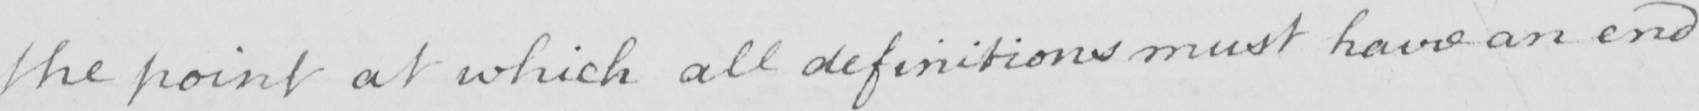Please provide the text content of this handwritten line. the point at which all definitions must have an end 